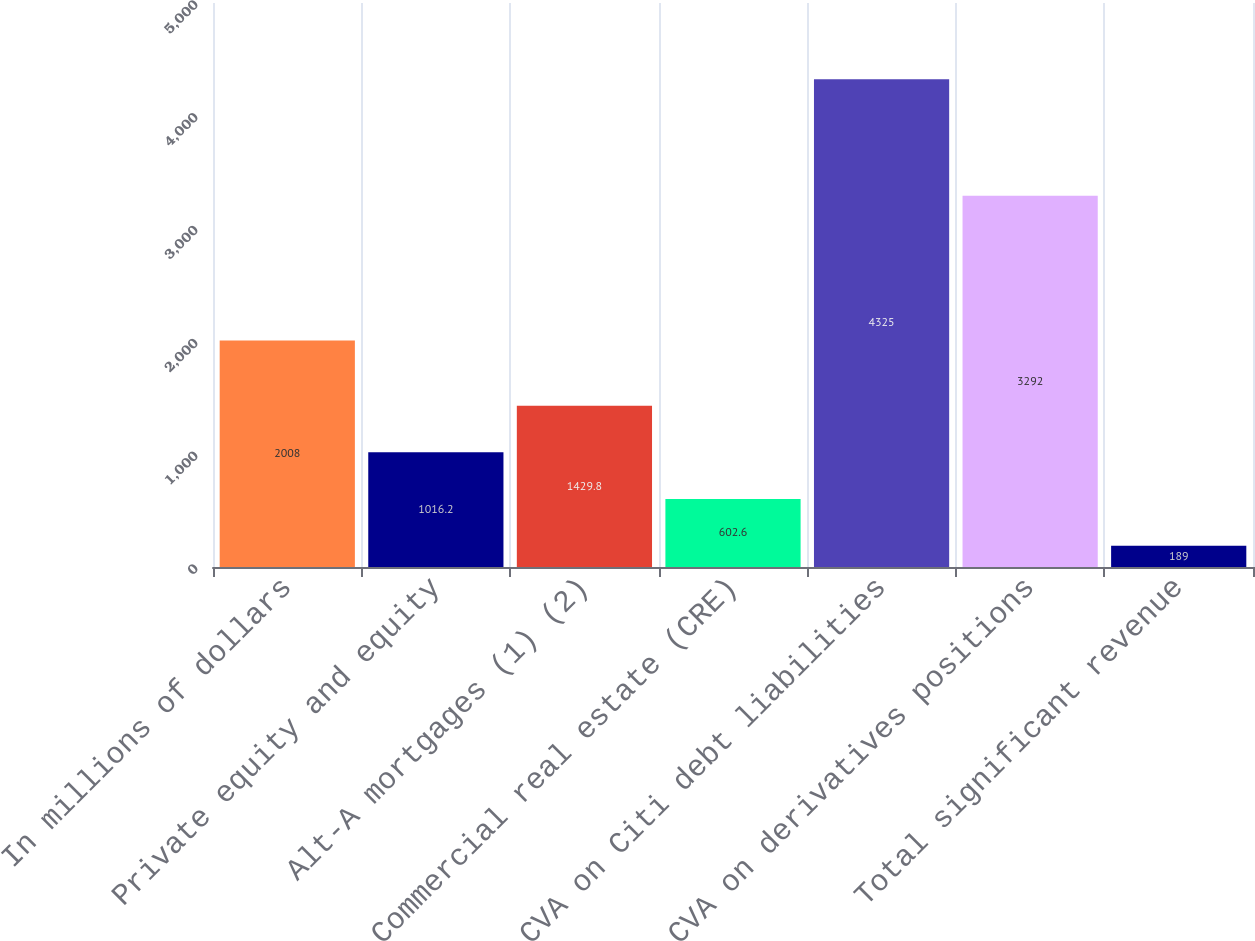Convert chart. <chart><loc_0><loc_0><loc_500><loc_500><bar_chart><fcel>In millions of dollars<fcel>Private equity and equity<fcel>Alt-A mortgages (1) (2)<fcel>Commercial real estate (CRE)<fcel>CVA on Citi debt liabilities<fcel>CVA on derivatives positions<fcel>Total significant revenue<nl><fcel>2008<fcel>1016.2<fcel>1429.8<fcel>602.6<fcel>4325<fcel>3292<fcel>189<nl></chart> 